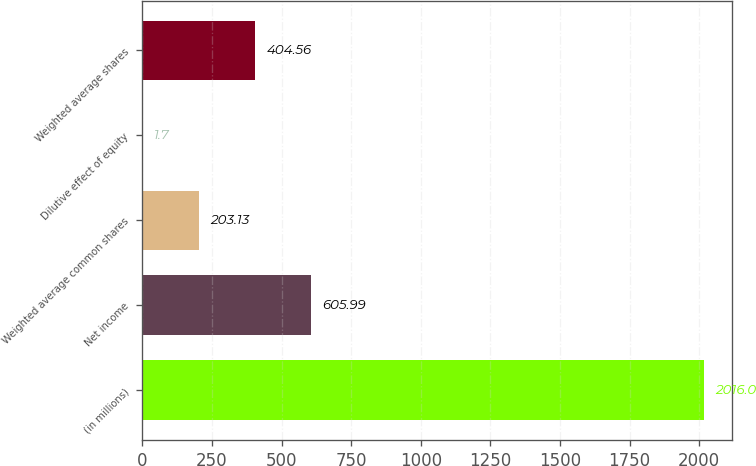<chart> <loc_0><loc_0><loc_500><loc_500><bar_chart><fcel>(in millions)<fcel>Net income<fcel>Weighted average common shares<fcel>Dilutive effect of equity<fcel>Weighted average shares<nl><fcel>2016<fcel>605.99<fcel>203.13<fcel>1.7<fcel>404.56<nl></chart> 